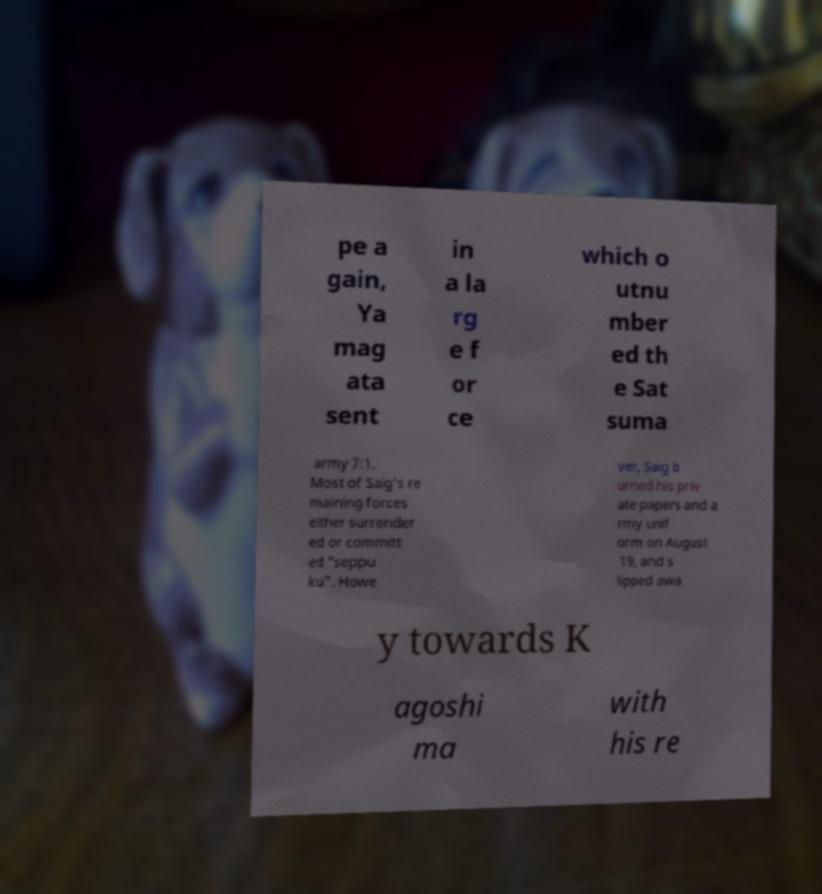There's text embedded in this image that I need extracted. Can you transcribe it verbatim? pe a gain, Ya mag ata sent in a la rg e f or ce which o utnu mber ed th e Sat suma army 7:1. Most of Saig's re maining forces either surrender ed or committ ed "seppu ku". Howe ver, Saig b urned his priv ate papers and a rmy unif orm on August 19, and s lipped awa y towards K agoshi ma with his re 